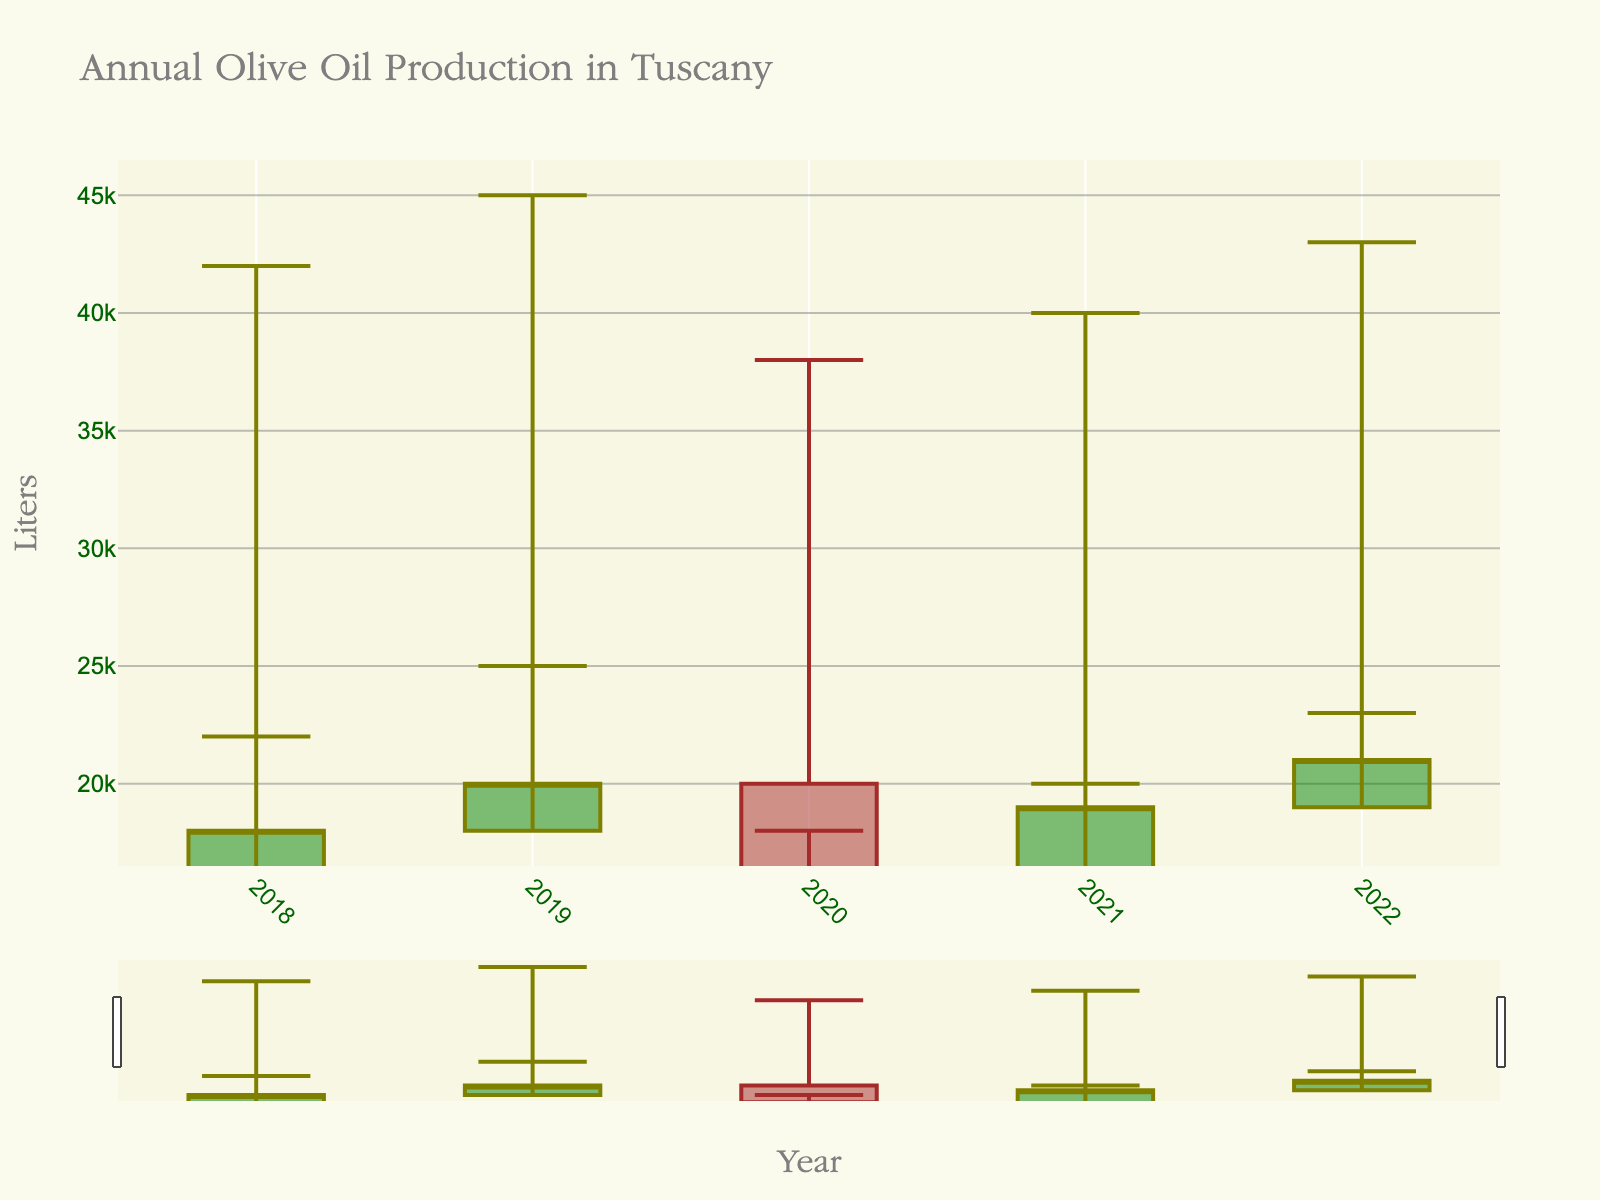what is the title of the plot? The title of the plot is usually located at the top of the chart and is used to describe the content or subject of the figure. In this figure, the title is clearly stated.
Answer: Annual Olive Oil Production in Tuscany Which year had the highest closing stock of olive oil? To find this information, look at the closing stock values on the y-axis and determine which year corresponds to the highest value.
Answer: 2022 What were the highest and lowest yields in 2020? Refer to the vertical lines on the OHLC chart for the year 2020, with the top of the line representing the highest yield and the bottom representing the lowest yield.
Answer: 38000 liters (Highest), 18000 liters (Lowest) What is the difference between the highest yield and the lowest yield in 2021? To find the difference, subtract the lowest yield from the highest yield for the year 2021. Highest yield: 40000, Lowest yield: 20000, Difference: 40000 - 20000
Answer: 20000 liters How did the starting inventory in 2022 compare with 2019? For this comparison, observe the starting inventory values for both years and determine whether they increased or decreased. In 2019, it was 18000 liters, and in 2022, it was 19000 liters.
Answer: Increased by 1000 liters Which year experienced the largest swing between the highest and lowest yields? To identify this, calculate the difference between the highest and lowest yields for each year and compare these differences. The year with the largest difference is the one with the largest swing.
Answer: 2019 What trend do you observe in the closing stock from 2018 to 2022? Look at the closing stock for each year and describe whether there is an increasing, decreasing, or mixed trend. From 2018 to 2022, the trend shows a general increase in the closing stock.
Answer: Increasing trend In what year was the difference between the starting inventory and closing stock the smallest? Calculate the difference between the starting inventory and closing stock for each year and identify the year with the smallest value. For each year: 2018 (15000-18000=-3000), 2019 (18000-20000=-2000), 2020 (20000-16000=4000), 2021 (16000-19000=-3000), 2022 (19000-21000=-2000). The smallest difference is in 2019 and 2022.
Answer: 2019 and 2022 